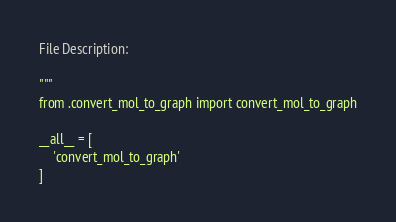Convert code to text. <code><loc_0><loc_0><loc_500><loc_500><_Python_>
File Description:

"""
from .convert_mol_to_graph import convert_mol_to_graph

__all__ = [
    'convert_mol_to_graph'
]</code> 